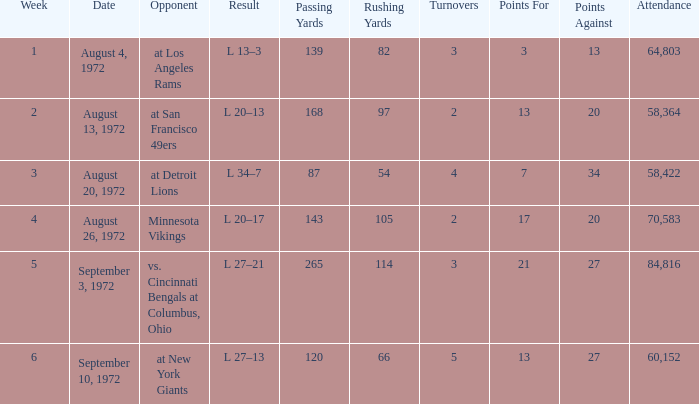What is the date of week 4? August 26, 1972. 